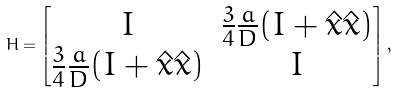<formula> <loc_0><loc_0><loc_500><loc_500>H = \begin{bmatrix} I & \frac { 3 } { 4 } \frac { a } { D } ( I + \hat { x } \hat { x } ) \\ \frac { 3 } { 4 } \frac { a } { D } ( I + \hat { x } \hat { x } ) & I \end{bmatrix} ,</formula> 